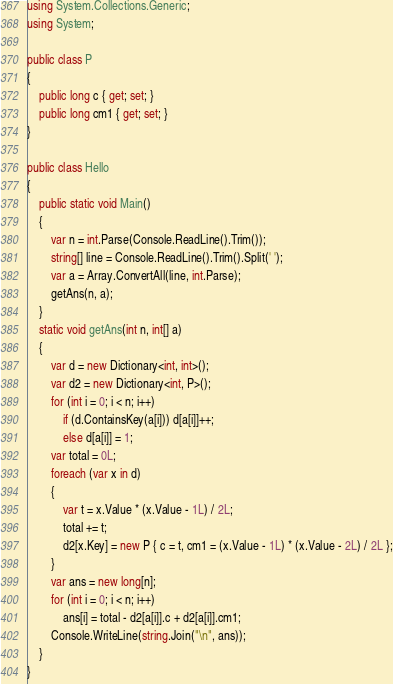<code> <loc_0><loc_0><loc_500><loc_500><_C#_>using System.Collections.Generic;
using System;

public class P
{
    public long c { get; set; }
    public long cm1 { get; set; }
}

public class Hello
{
    public static void Main()
    {
        var n = int.Parse(Console.ReadLine().Trim());
        string[] line = Console.ReadLine().Trim().Split(' ');
        var a = Array.ConvertAll(line, int.Parse);
        getAns(n, a);
    }
    static void getAns(int n, int[] a)
    {
        var d = new Dictionary<int, int>();
        var d2 = new Dictionary<int, P>();
        for (int i = 0; i < n; i++)
            if (d.ContainsKey(a[i])) d[a[i]]++;
            else d[a[i]] = 1;
        var total = 0L;
        foreach (var x in d)
        {
            var t = x.Value * (x.Value - 1L) / 2L;
            total += t;
            d2[x.Key] = new P { c = t, cm1 = (x.Value - 1L) * (x.Value - 2L) / 2L };
        }
        var ans = new long[n];
        for (int i = 0; i < n; i++)
            ans[i] = total - d2[a[i]].c + d2[a[i]].cm1;
        Console.WriteLine(string.Join("\n", ans));
    }
}
</code> 